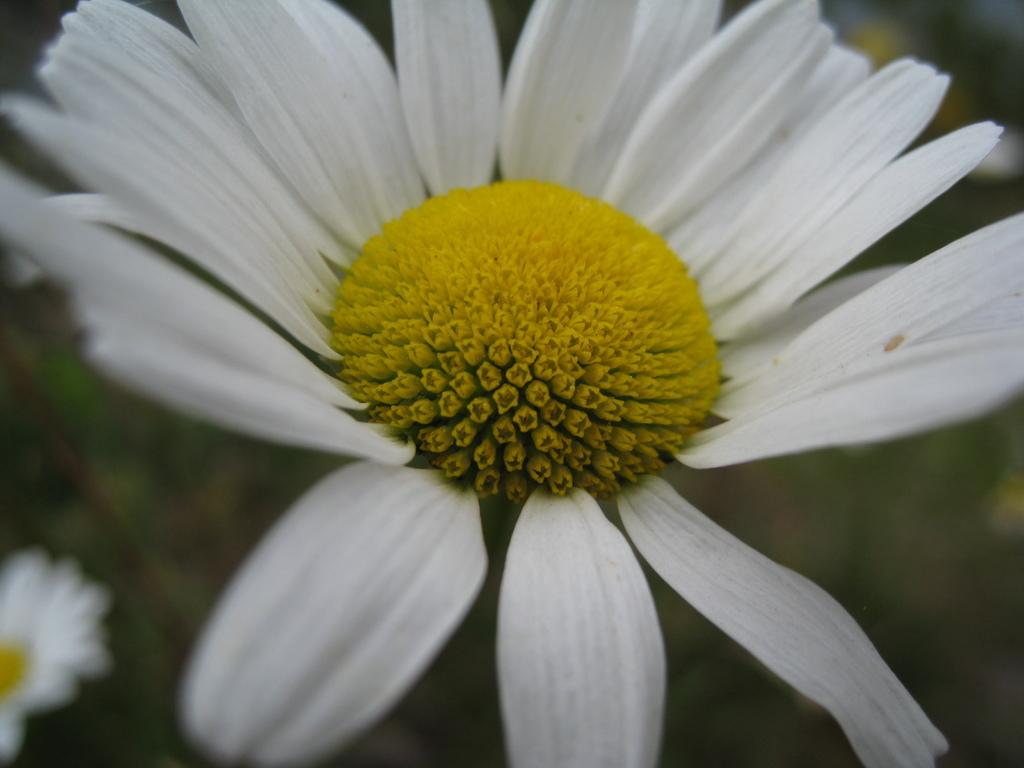What type of living organisms can be seen in the image? There are flowers in the image. Can you describe the background of the image? The background of the image is blurred. How many volcanoes can be seen in the image? There are no volcanoes present in the image. What is the son doing in the image? There is no son present in the image. 